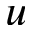Convert formula to latex. <formula><loc_0><loc_0><loc_500><loc_500>u</formula> 